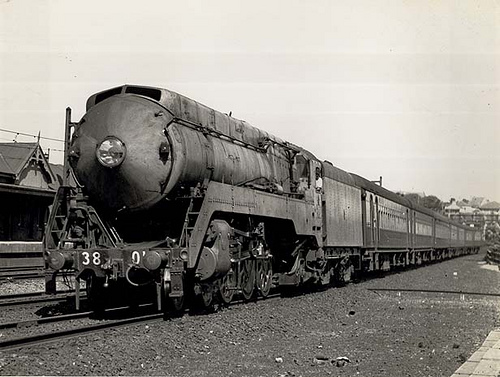Please transcribe the text information in this image. 3 8 0 